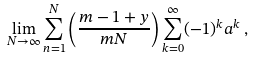<formula> <loc_0><loc_0><loc_500><loc_500>\lim _ { N \rightarrow \infty } \sum _ { n = 1 } ^ { N } \left ( \frac { m - 1 + y } { m N } \right ) \sum _ { k = 0 } ^ { \infty } ( - 1 ) ^ { k } a ^ { k } \, ,</formula> 